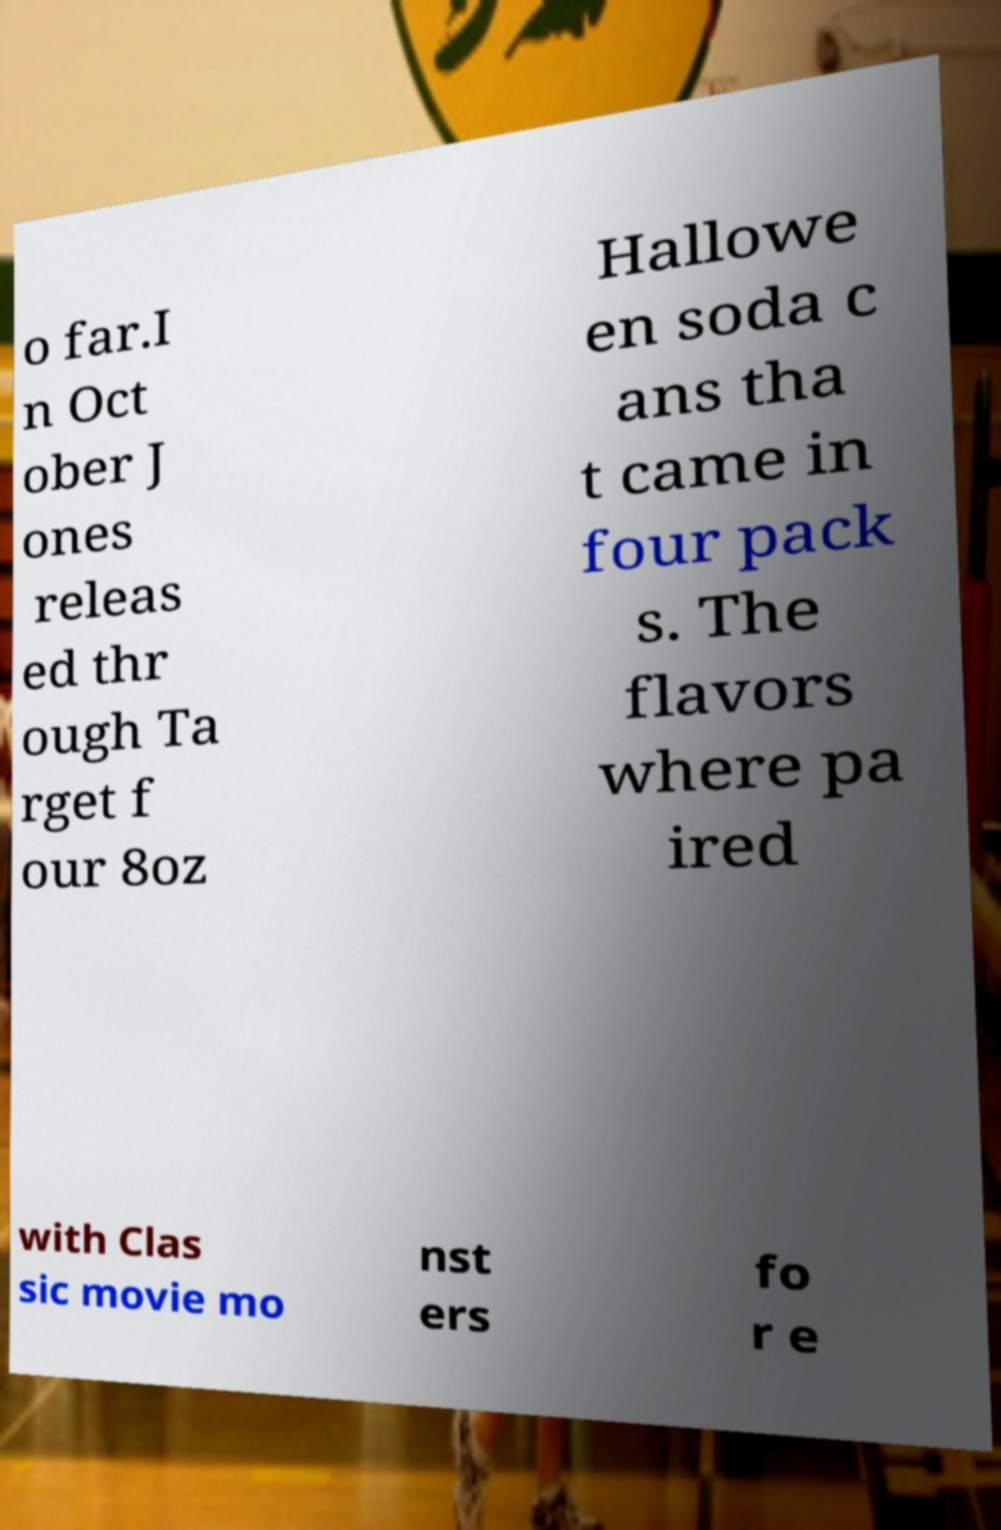Can you read and provide the text displayed in the image?This photo seems to have some interesting text. Can you extract and type it out for me? o far.I n Oct ober J ones releas ed thr ough Ta rget f our 8oz Hallowe en soda c ans tha t came in four pack s. The flavors where pa ired with Clas sic movie mo nst ers fo r e 